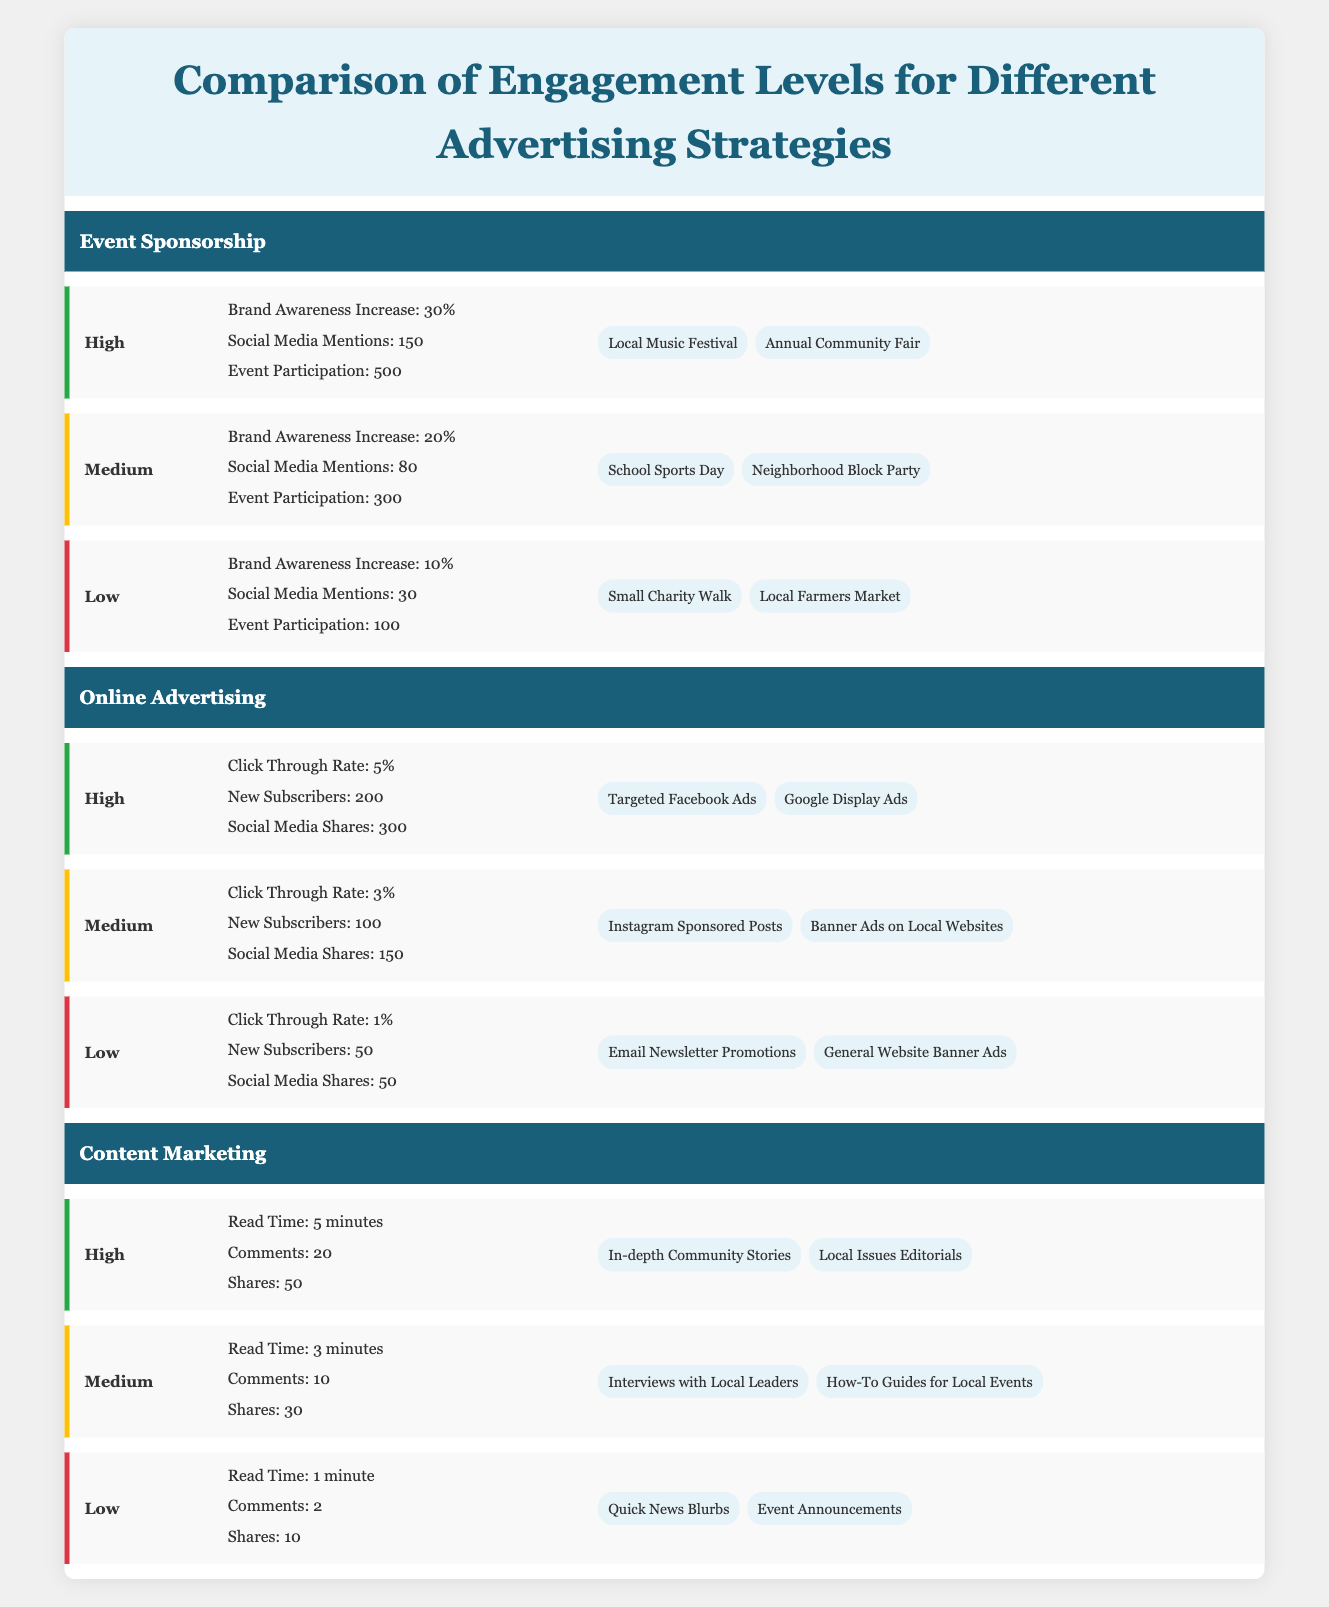What is the Brand Awareness Increase percentage for High Engagement Level under Event Sponsorship? The table indicates that for the High Engagement Level under Event Sponsorship, the Brand Awareness Increase is 30%.
Answer: 30% What is the Click Through Rate for the Low Engagement Level under Online Advertising? In the Online Advertising section, the Low Engagement Level has a Click Through Rate of 1%.
Answer: 1% How many Social Media Mentions are reported for the Medium Engagement Level in Event Sponsorship? According to the table, the Medium Engagement Level in Event Sponsorship has 80 Social Media Mentions.
Answer: 80 Which advertising strategy has the highest Engagement Level for New Subscribers? Looking at the New Subscribers metric, Online Advertising at High Engagement Level has 200 New Subscribers, which is the highest compared to other strategies.
Answer: Online Advertising What is the average Event Participation for all Engagement Levels under Event Sponsorship? For High, Medium, and Low Engagement Levels under Event Sponsorship, the Event Participation figures are 500, 300, and 100 respectively. Adding these gives a total of 900, then dividing by 3 (the number of Engagement Levels) gives an average of 300.
Answer: 300 Is the average Read Time for High Engagement Content Marketing greater than 4 minutes? The Read Time for High Engagement is 5 minutes, which is indeed greater than 4 minutes. Thus, the answer to the question is yes.
Answer: Yes Do Online Advertising strategies generally perform better in Social Media Shares compared to Content Marketing? In High Engagement Level, Online Advertising has 300 Social Media Shares, while Content Marketing has 50. While in Low Engagement Level, Online Advertising has 50, and Content Marketing has 10. The overall trends in the table show Online Advertising generally performs better in Social Media Shares across different levels.
Answer: Yes What is the total increase in Brand Awareness for all levels in Event Sponsorship? The Brand Awareness increases for High, Medium, and Low levels are 30%, 20%, and 10%, respectively. Adding these gives a total increase of 60%.
Answer: 60% Are there more Examples for High Engagement Level in Content Marketing than for Low Engagement Level in Event Sponsorship? The table states there are 2 Examples listed for High Engagement Level in Content Marketing and 2 Examples for Low Engagement Level in Event Sponsorship as well. Therefore, there is no difference in the number of Examples.
Answer: No 